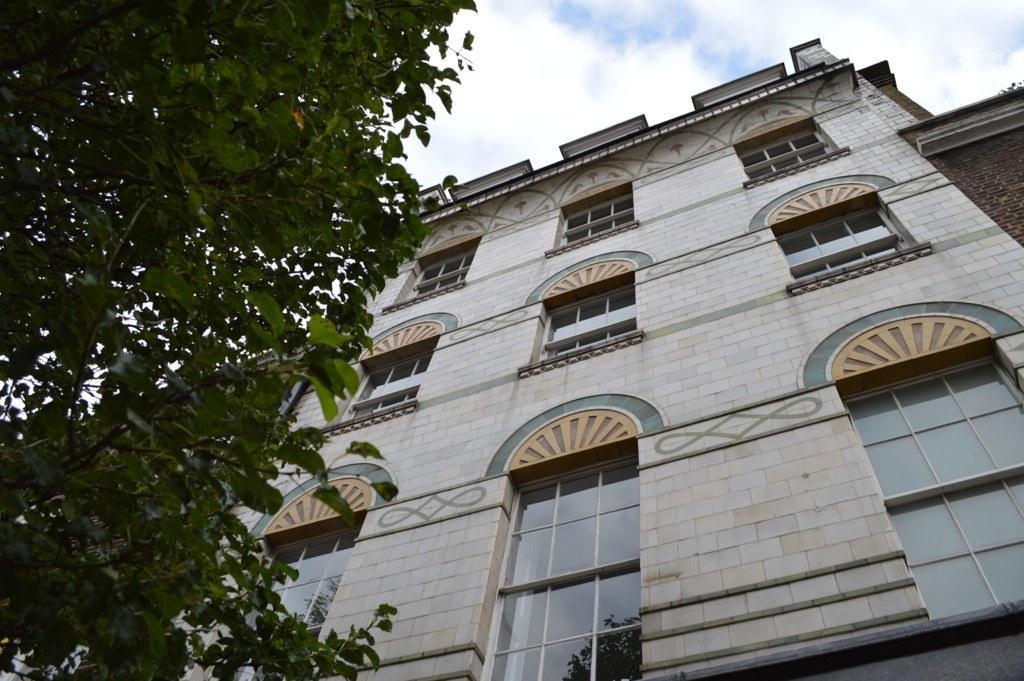Could you give a brief overview of what you see in this image? In this image we can see a building, trees and a sky. 